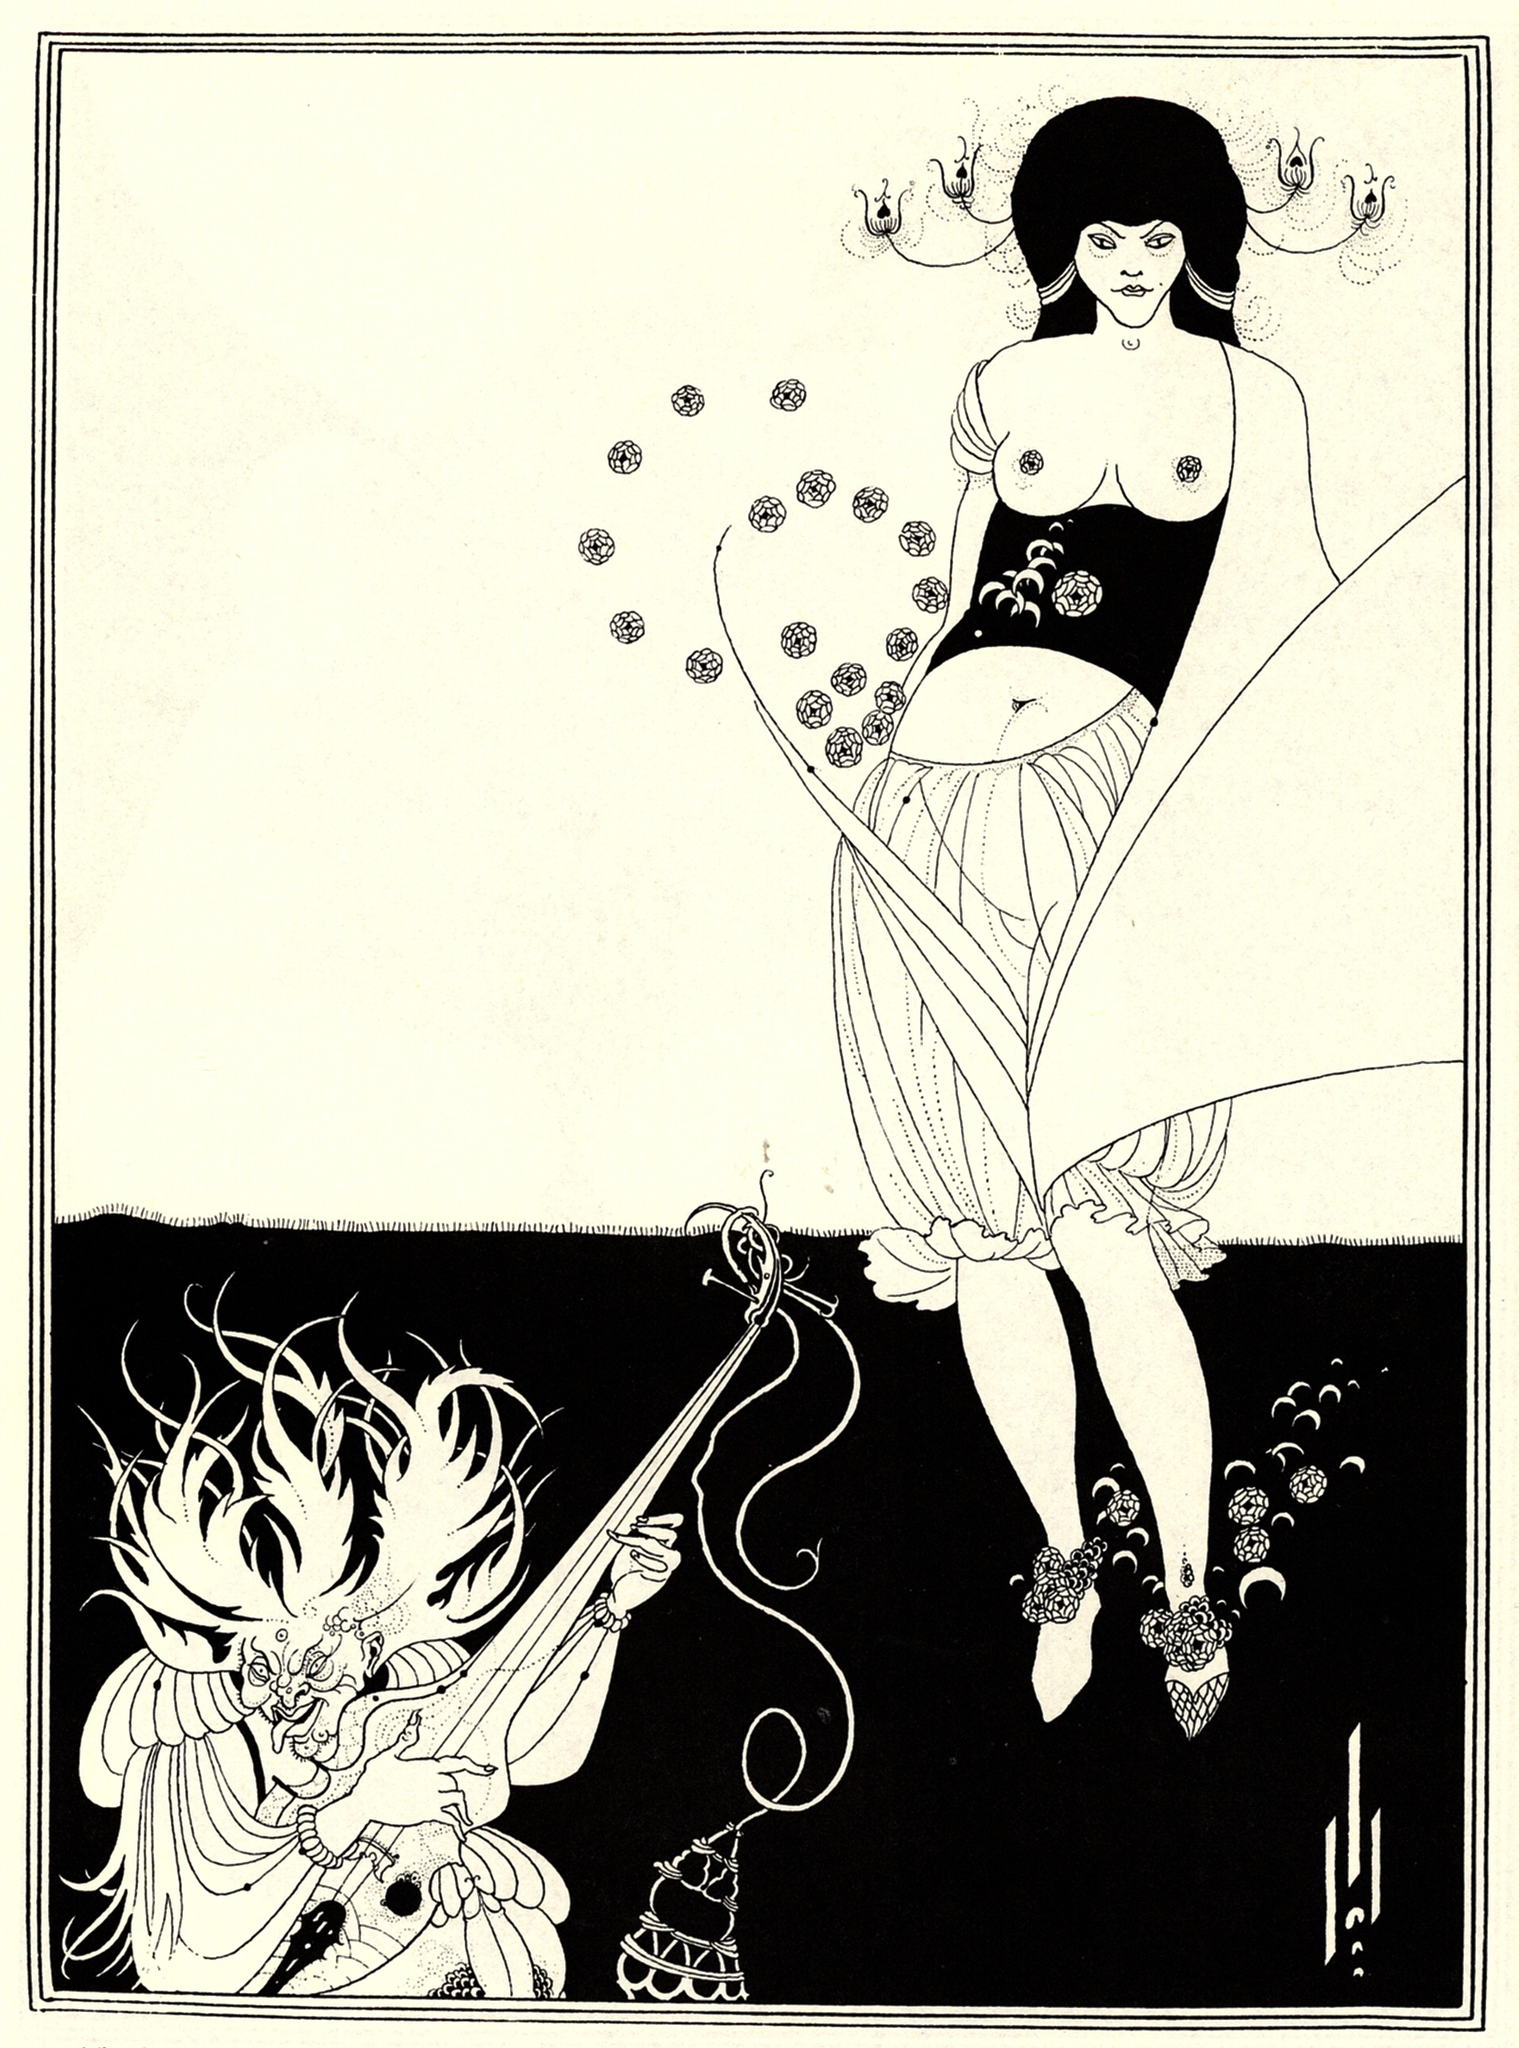What kind of relationship do you think exists between the woman and the dragon? The relationship between the woman and the dragon can be interpreted in various ways depending on the narrative context. They could be adversaries, locked in an eternal struggle where each symbolizes opposing forces: the woman as the harbinger of light, nature, and order, while the dragon represents chaos, darkness, and ancient power.

Alternatively, they might share a symbiotic bond, where the woman is the dragon's master or ally, each entity complementing the other's abilities. In this scenario, their interactions would be marked by a blend of mutual respect and reliance, working together to maintain balance in their fantastical world. The woman might utilize the dragon's strength and mystical abilities to safeguard her people, while the dragon gains purpose and direction through their partnership. 